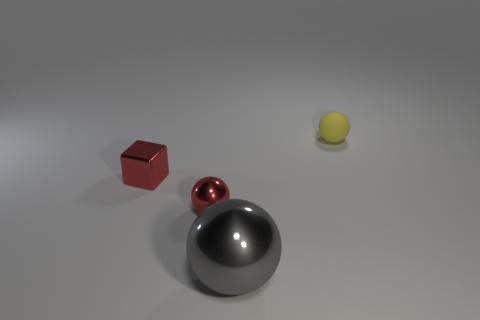Add 3 tiny yellow spheres. How many objects exist? 7 Subtract all spheres. How many objects are left? 1 Subtract 0 cyan cylinders. How many objects are left? 4 Subtract all tiny cubes. Subtract all red metal spheres. How many objects are left? 2 Add 2 tiny red balls. How many tiny red balls are left? 3 Add 2 tiny rubber balls. How many tiny rubber balls exist? 3 